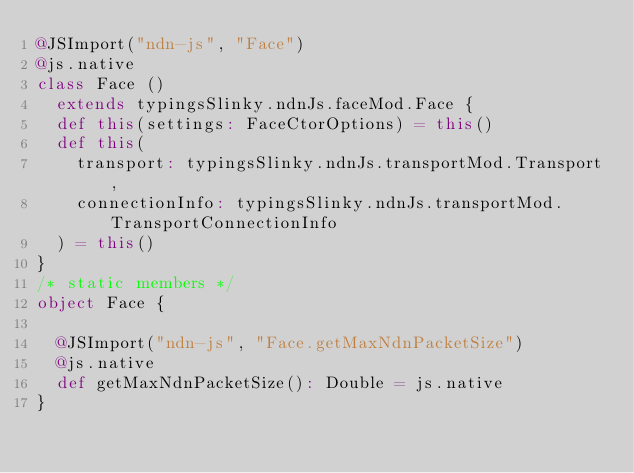<code> <loc_0><loc_0><loc_500><loc_500><_Scala_>@JSImport("ndn-js", "Face")
@js.native
class Face ()
  extends typingsSlinky.ndnJs.faceMod.Face {
  def this(settings: FaceCtorOptions) = this()
  def this(
    transport: typingsSlinky.ndnJs.transportMod.Transport,
    connectionInfo: typingsSlinky.ndnJs.transportMod.TransportConnectionInfo
  ) = this()
}
/* static members */
object Face {
  
  @JSImport("ndn-js", "Face.getMaxNdnPacketSize")
  @js.native
  def getMaxNdnPacketSize(): Double = js.native
}
</code> 